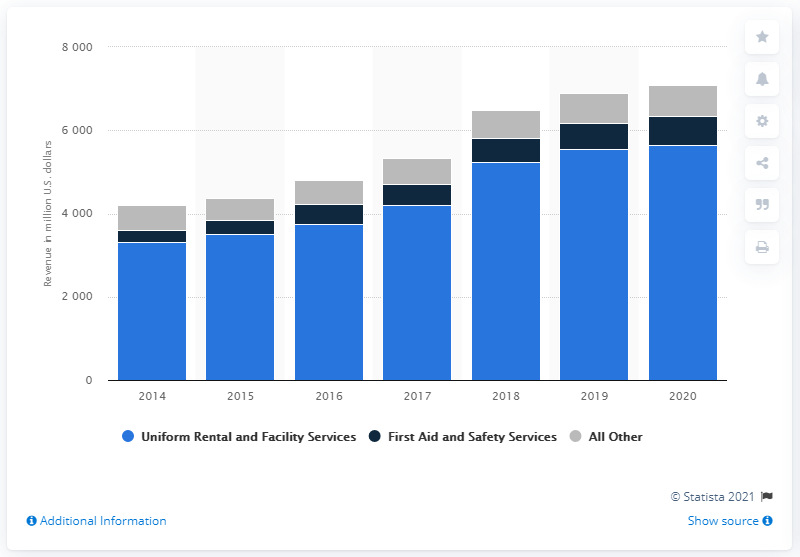Mention a couple of crucial points in this snapshot. In the fiscal year of 2020, Cintas Corporation's annual revenue was approximately 56,434.90. 